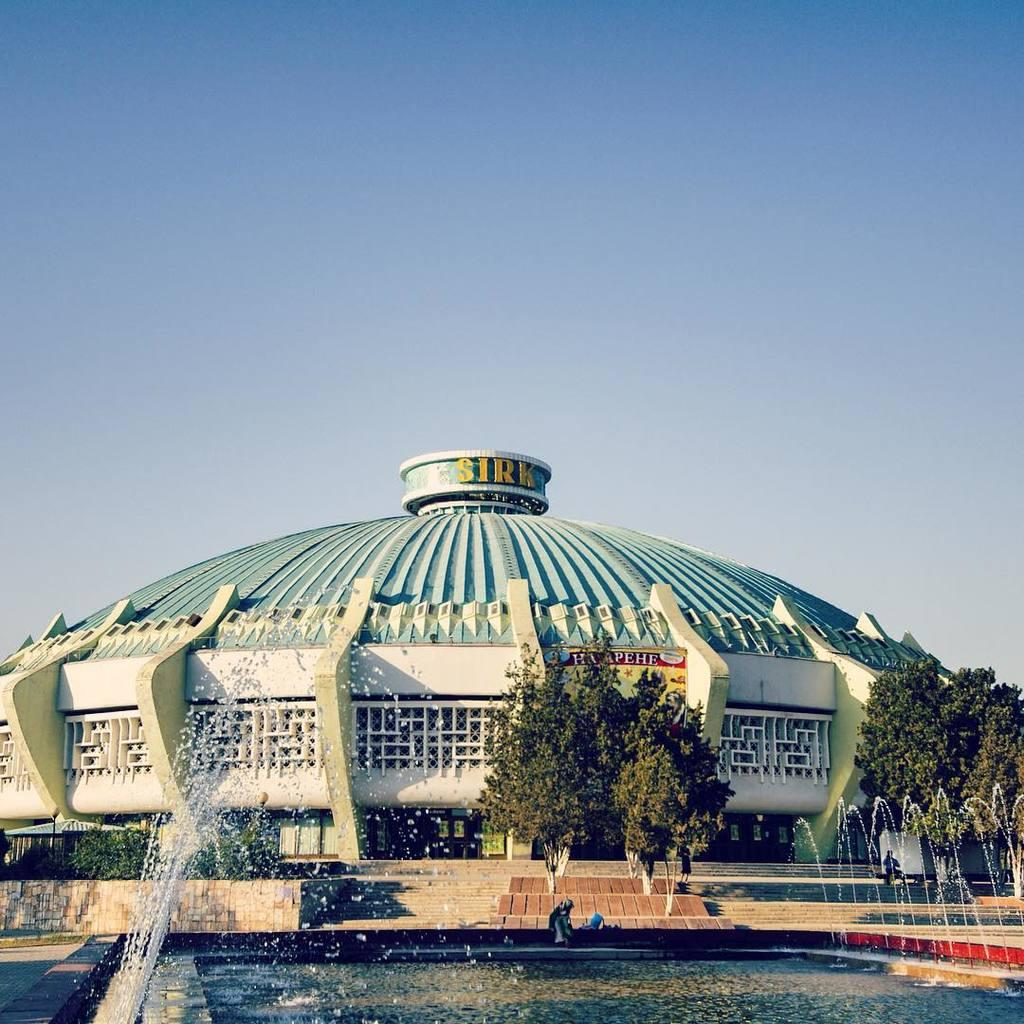What is the main structure in the center of the image? There is a building in the center of the image. What can be seen at the bottom of the image? Trees and water are visible at the bottom of the image. What feature is present at the bottom of the image? A water fountain is present at the bottom of the image. What is visible in the background of the image? The sky is visible in the background of the image. What type of powder is being used to create the stone texture on the building? There is no mention of powder or stone texture on the building in the image. 